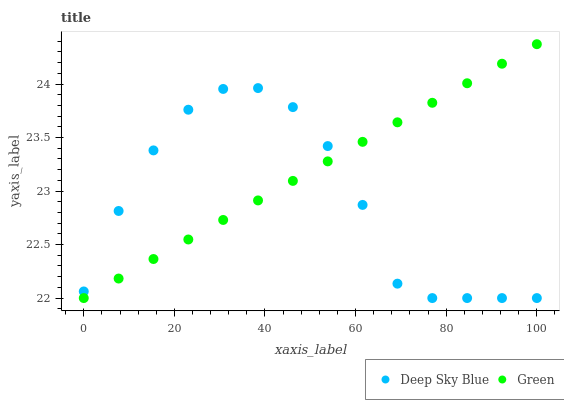Does Deep Sky Blue have the minimum area under the curve?
Answer yes or no. Yes. Does Green have the maximum area under the curve?
Answer yes or no. Yes. Does Deep Sky Blue have the maximum area under the curve?
Answer yes or no. No. Is Green the smoothest?
Answer yes or no. Yes. Is Deep Sky Blue the roughest?
Answer yes or no. Yes. Is Deep Sky Blue the smoothest?
Answer yes or no. No. Does Green have the lowest value?
Answer yes or no. Yes. Does Green have the highest value?
Answer yes or no. Yes. Does Deep Sky Blue have the highest value?
Answer yes or no. No. Does Deep Sky Blue intersect Green?
Answer yes or no. Yes. Is Deep Sky Blue less than Green?
Answer yes or no. No. Is Deep Sky Blue greater than Green?
Answer yes or no. No. 